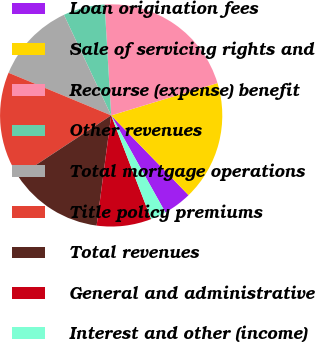<chart> <loc_0><loc_0><loc_500><loc_500><pie_chart><fcel>Loan origination fees<fcel>Sale of servicing rights and<fcel>Recourse (expense) benefit<fcel>Other revenues<fcel>Total mortgage operations<fcel>Title policy premiums<fcel>Total revenues<fcel>General and administrative<fcel>Interest and other (income)<nl><fcel>4.15%<fcel>17.44%<fcel>21.24%<fcel>6.05%<fcel>11.74%<fcel>15.54%<fcel>13.64%<fcel>7.95%<fcel>2.25%<nl></chart> 